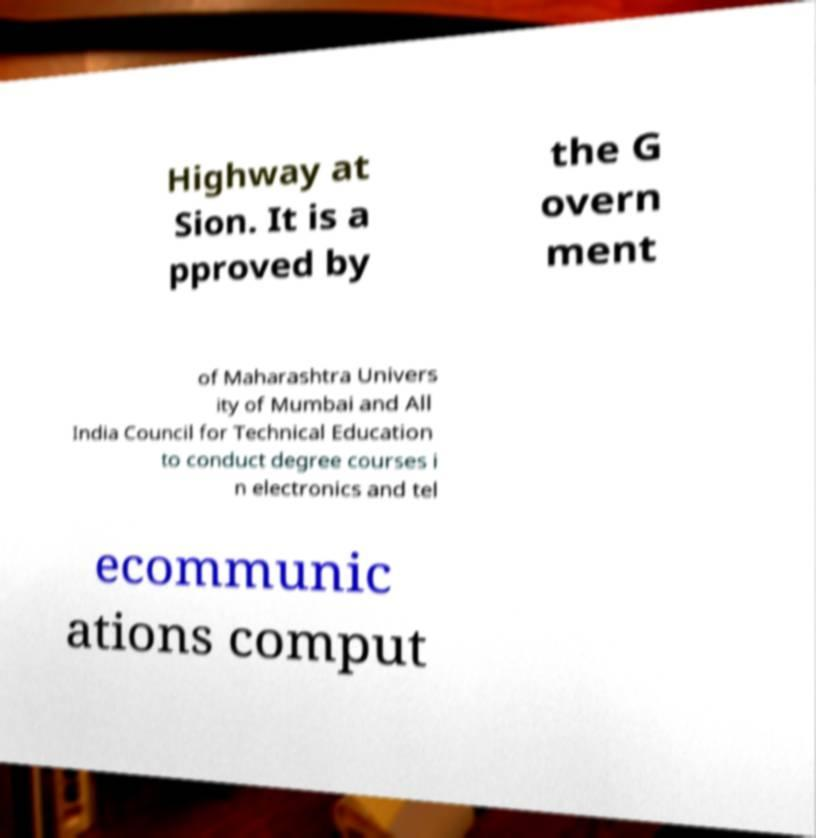Can you read and provide the text displayed in the image?This photo seems to have some interesting text. Can you extract and type it out for me? Highway at Sion. It is a pproved by the G overn ment of Maharashtra Univers ity of Mumbai and All India Council for Technical Education to conduct degree courses i n electronics and tel ecommunic ations comput 